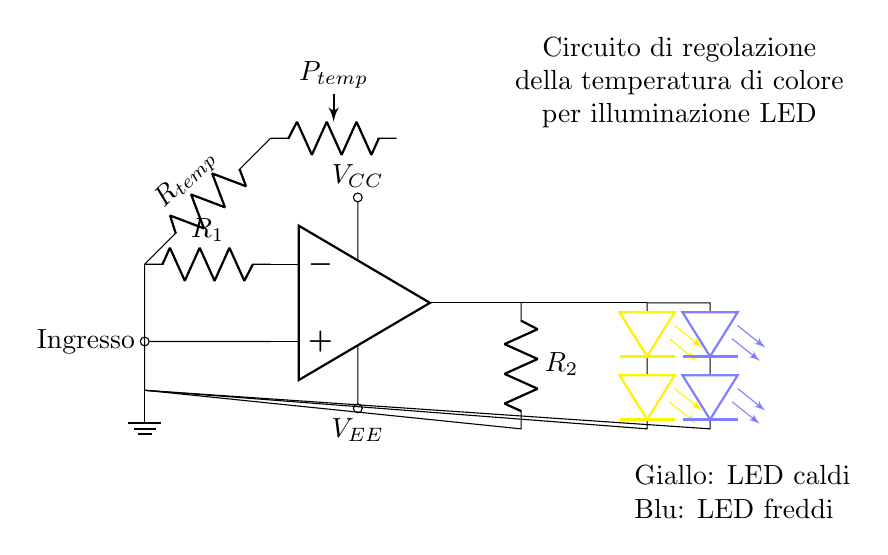What is the power supply voltage labeled in the circuit? The power supply voltage is indicated by the labels VCC and VEE next to the power connections. VCC represents the positive voltage, and VEE represents the negative voltage.
Answer: VCC and VEE What type of feedback component is used in this circuit? The feedback component is represented by the resistor labeled R1, which connects from the output to the inverting input of the operational amplifier. This is essential for setting the gain and controlling the operation of the op-amp.
Answer: Resistor How many LED strings are connected in the circuit? The circuit diagram shows two sets of LED strings: one string is yellow (warm LEDs), and the other string is blue (cool LEDs). These are drawn in parallel from the output.
Answer: Two What does the Rtemp component control in this circuit? The Rtemp component, which is labeled in the feedback path, adjusts the feedback signal's level and thus influences the output voltage controlling the color temperature of the LED lighting. This indicates its role in modifying the overall operating point of the op-amp, leading to different color outputs.
Answer: Color temperature Which color of LED represents warm lighting in the circuit? The circuit diagram shows a yellow LED string labeled as warm lighting, contrasting with the blue LED string labeled as cool lighting. This distinction helps in understanding which LED emits a warmer tone beneficial for food presentation.
Answer: Yellow What is the function of the operational amplifier in this circuit? The operational amplifier acts as a voltage controller that takes an input signal and amplifies it while controlling the output LED power based on the feedback from R1 and Rtemp. This configuration allows it to adjust color temperature according to the desired settings for food presentation.
Answer: Voltage controller What type of component is Ptemp in the circuit? The Ptemp component is labeled as a potentiometer in the circuit, allowing for variable resistance. This component enables the user to manually adjust the resistance and thus modify the intensity or other characteristics of the output, affecting the LED's color output for better presentation.
Answer: Potentiometer 